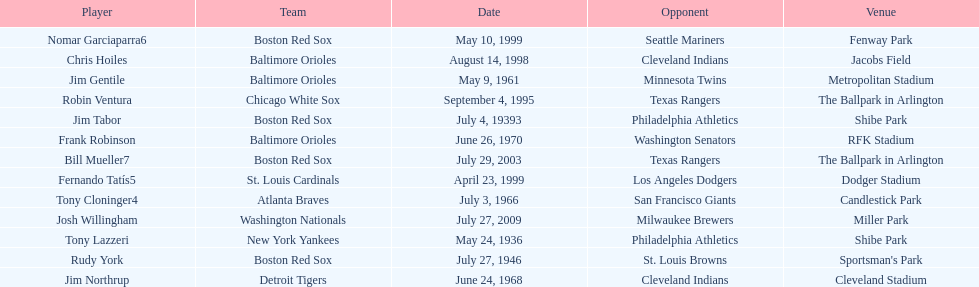What is the number of times a boston red sox player has had two grand slams in one game? 4. 